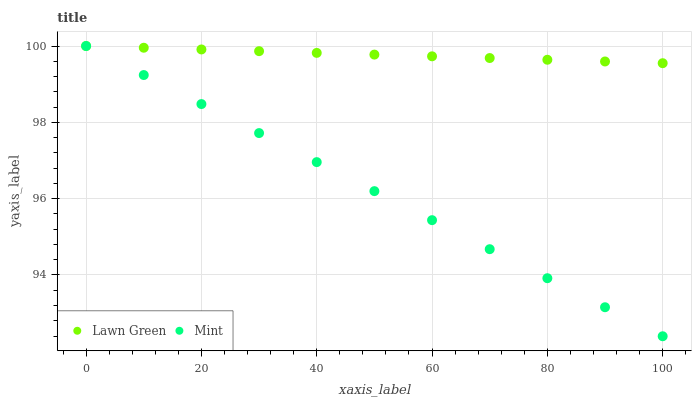Does Mint have the minimum area under the curve?
Answer yes or no. Yes. Does Lawn Green have the maximum area under the curve?
Answer yes or no. Yes. Does Mint have the maximum area under the curve?
Answer yes or no. No. Is Lawn Green the smoothest?
Answer yes or no. Yes. Is Mint the roughest?
Answer yes or no. Yes. Is Mint the smoothest?
Answer yes or no. No. Does Mint have the lowest value?
Answer yes or no. Yes. Does Mint have the highest value?
Answer yes or no. Yes. Does Mint intersect Lawn Green?
Answer yes or no. Yes. Is Mint less than Lawn Green?
Answer yes or no. No. Is Mint greater than Lawn Green?
Answer yes or no. No. 